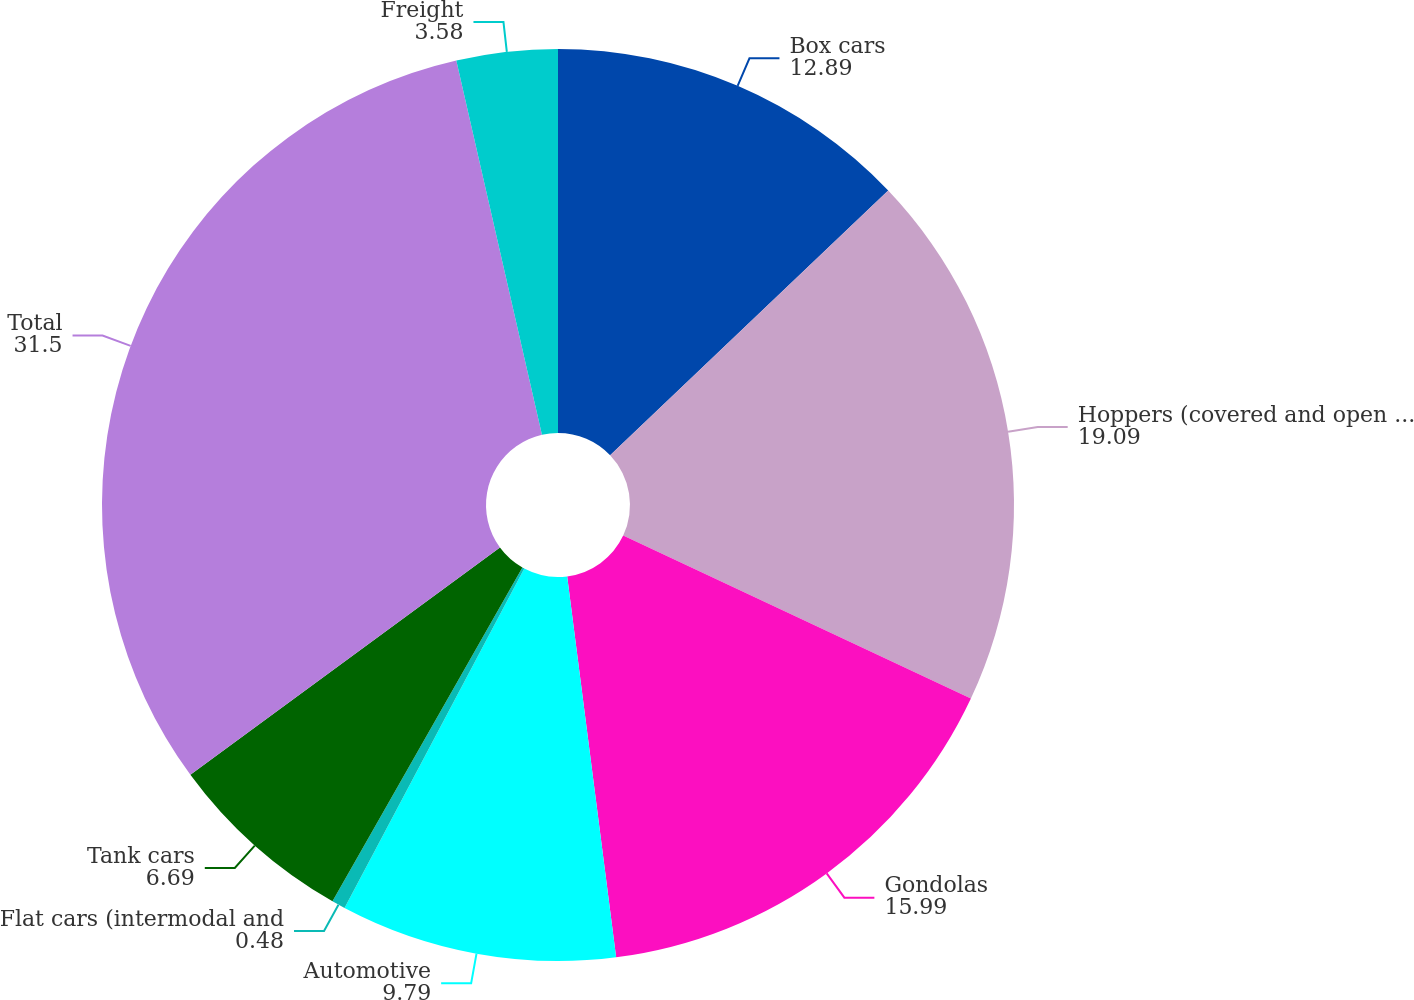Convert chart. <chart><loc_0><loc_0><loc_500><loc_500><pie_chart><fcel>Box cars<fcel>Hoppers (covered and open top)<fcel>Gondolas<fcel>Automotive<fcel>Flat cars (intermodal and<fcel>Tank cars<fcel>Total<fcel>Freight<nl><fcel>12.89%<fcel>19.09%<fcel>15.99%<fcel>9.79%<fcel>0.48%<fcel>6.69%<fcel>31.5%<fcel>3.58%<nl></chart> 